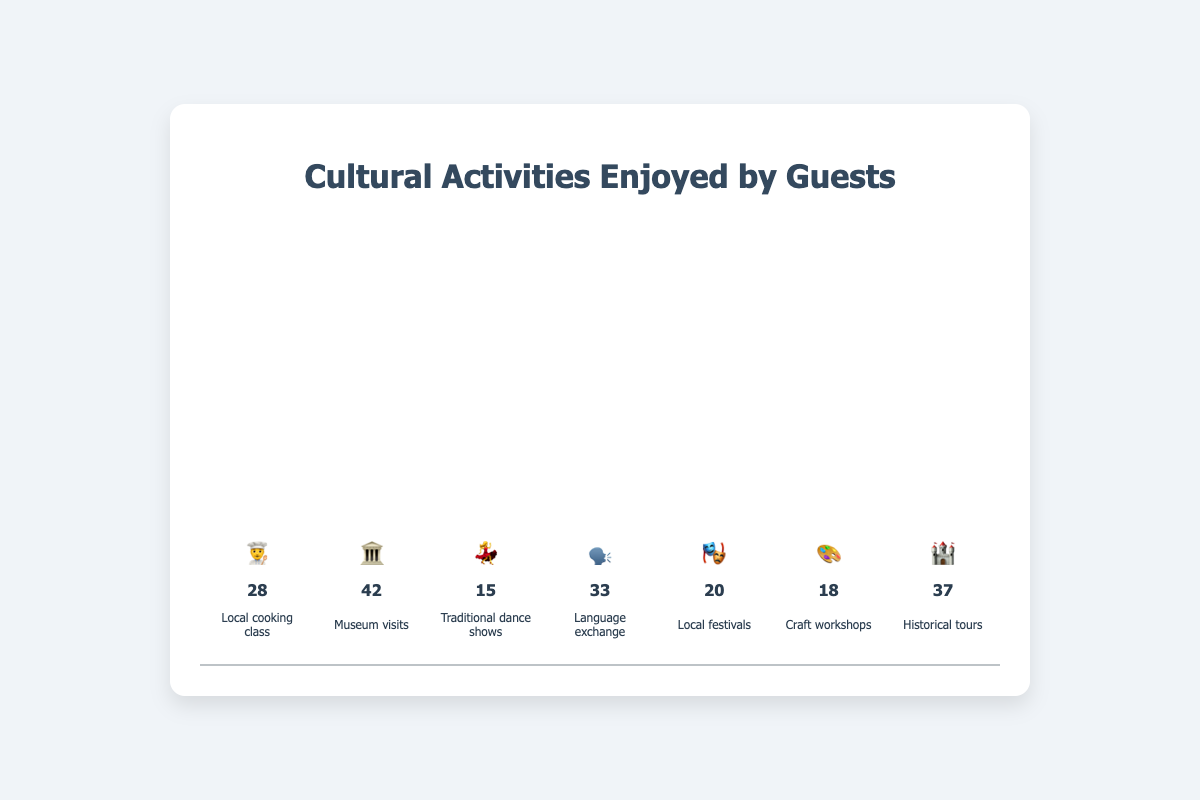What is the most popular cultural activity enjoyed by guests? The tallest bar in the chart corresponds to the "Museum visits" activity with an emoji 🏛️, and it has the highest count of 42.
Answer: Museum visits Which cultural activity has the least participation? The shortest bar in the chart corresponds to "Traditional dance shows" with an emoji 💃, and it has the lowest count of 15.
Answer: Traditional dance shows How many guests participated in the Historical tours? The bar for "Historical tours" is depicted with an emoji 🏰 and shows a count of 37.
Answer: 37 If you add the counts of Local cooking class and Craft workshops, what is the total? The Local cooking class has a count of 28 and the Craft workshops have a count of 18. Adding these together gives 28 + 18 = 46.
Answer: 46 Which is more popular, Language exchange or Local festivals? Comparing the bar heights and counts, Language exchange has a count of 33 while Local festivals have a count of 20.
Answer: Language exchange What emoji represents the Local festivals activity? The Local festivals activity is depicted with the emoji 🎭 in the chart.
Answer: 🎭 If a new cultural activity is added with a count of 25, where would it approximately rank in popularity among the existing activities? If an activity with a count of 25 is added, it would be more than Traditional dance shows, Craft workshops, Local festivals, and less than Local cooking class, ranking it fifth in popularity.
Answer: Fifth Compare the participation in Museum visits and Local cooking class. How many more guests enjoyed Museum visits compared to Local cooking class? Museum visits have a count of 42 while Local cooking class has a count of 28. Subtracting these gives 42 - 28 = 14 more guests for Museum visits.
Answer: 14 What is the combined count of all cultural activities enjoyed by guests? Summing up all the counts: 28 (Local cooking class) + 42 (Museum visits) + 15 (Traditional dance shows) + 33 (Language exchange) + 20 (Local festivals) + 18 (Craft workshops) + 37 (Historical tours) = 193.
Answer: 193 